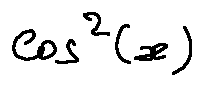<formula> <loc_0><loc_0><loc_500><loc_500>\cos ^ { 2 } ( x )</formula> 